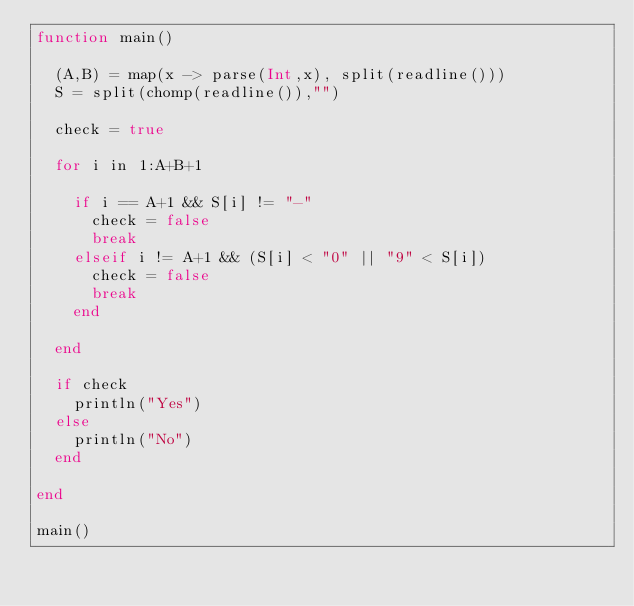<code> <loc_0><loc_0><loc_500><loc_500><_Julia_>function main()
  
  (A,B) = map(x -> parse(Int,x), split(readline()))
  S = split(chomp(readline()),"")
  
  check = true
  
  for i in 1:A+B+1
    
    if i == A+1 && S[i] != "-"
      check = false
      break
    elseif i != A+1 && (S[i] < "0" || "9" < S[i])
      check = false
      break
    end
    
  end
  
  if check
  	println("Yes")
  else
    println("No")
  end
  
end

main()</code> 